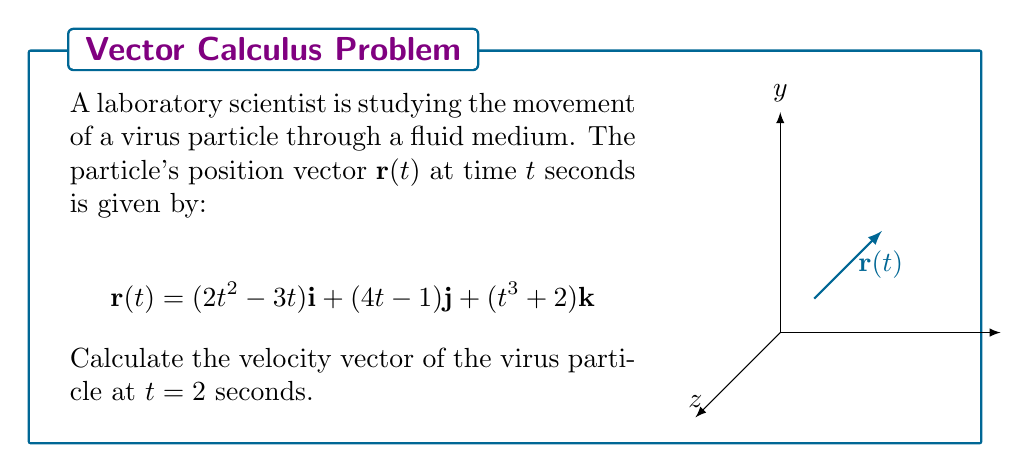Solve this math problem. To find the velocity vector, we need to differentiate the position vector with respect to time. The velocity vector $\mathbf{v}(t)$ is given by:

$$\mathbf{v}(t) = \frac{d\mathbf{r}(t)}{dt}$$

Let's differentiate each component:

1) For the i-component:
   $$\frac{d}{dt}(2t^2 - 3t) = 4t - 3$$

2) For the j-component:
   $$\frac{d}{dt}(4t - 1) = 4$$

3) For the k-component:
   $$\frac{d}{dt}(t^3 + 2) = 3t^2$$

Therefore, the velocity vector is:

$$\mathbf{v}(t) = (4t - 3)\mathbf{i} + 4\mathbf{j} + 3t^2\mathbf{k}$$

To find the velocity at $t = 2$ seconds, we substitute $t = 2$ into this expression:

$$\begin{align*}
\mathbf{v}(2) &= (4(2) - 3)\mathbf{i} + 4\mathbf{j} + 3(2)^2\mathbf{k} \\
&= 5\mathbf{i} + 4\mathbf{j} + 12\mathbf{k}
\end{align*}$$
Answer: $5\mathbf{i} + 4\mathbf{j} + 12\mathbf{k}$ 